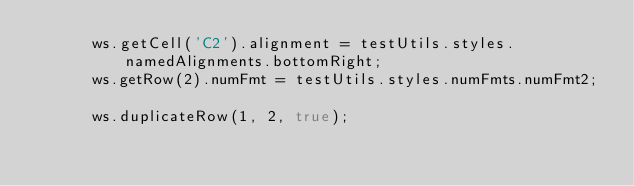Convert code to text. <code><loc_0><loc_0><loc_500><loc_500><_JavaScript_>      ws.getCell('C2').alignment = testUtils.styles.namedAlignments.bottomRight;
      ws.getRow(2).numFmt = testUtils.styles.numFmts.numFmt2;

      ws.duplicateRow(1, 2, true);</code> 